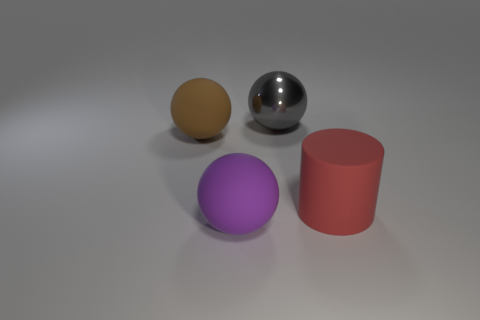Add 1 rubber cylinders. How many objects exist? 5 Subtract all cylinders. How many objects are left? 3 Add 1 big rubber cylinders. How many big rubber cylinders exist? 2 Subtract 0 blue blocks. How many objects are left? 4 Subtract all big brown matte spheres. Subtract all tiny yellow cylinders. How many objects are left? 3 Add 3 spheres. How many spheres are left? 6 